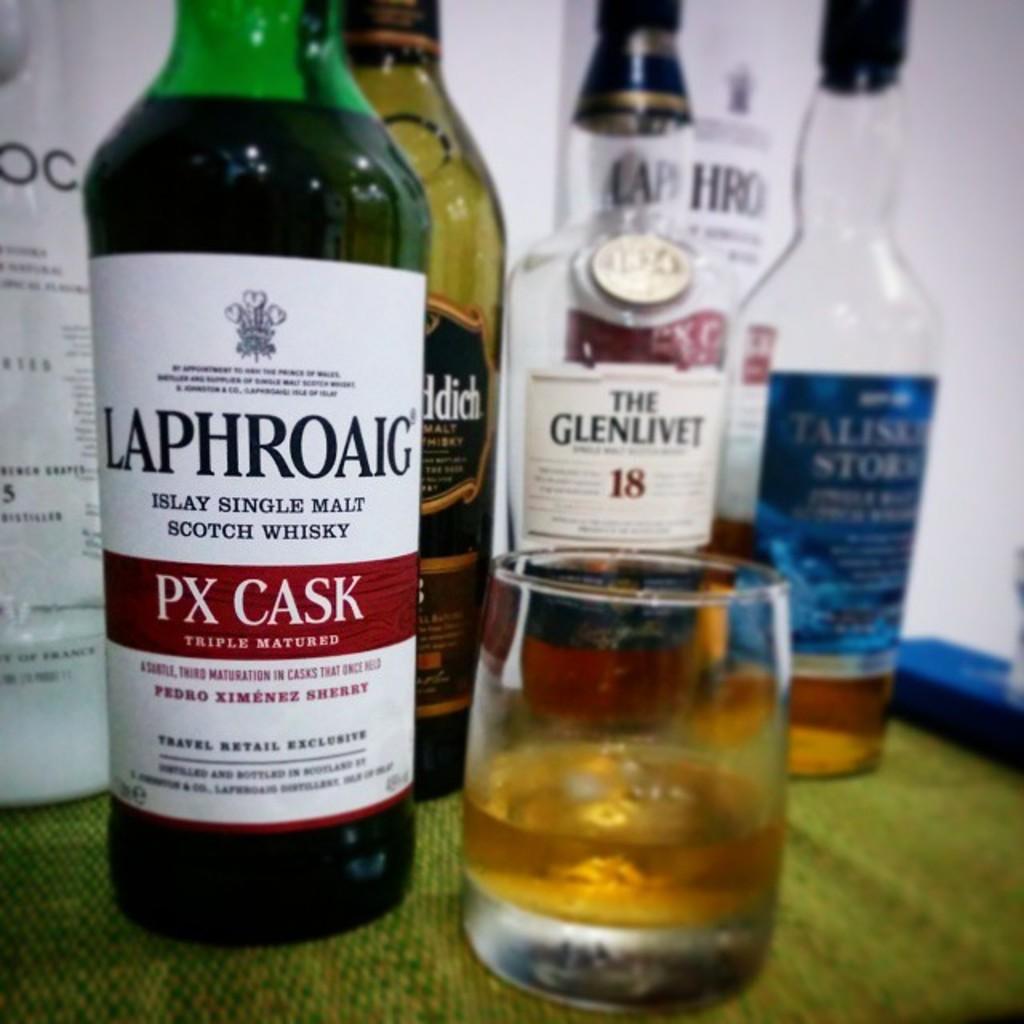How many times is the drink malted?
Make the answer very short. Single. 